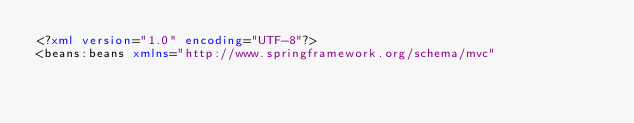Convert code to text. <code><loc_0><loc_0><loc_500><loc_500><_XML_><?xml version="1.0" encoding="UTF-8"?>
<beans:beans xmlns="http://www.springframework.org/schema/mvc"</code> 